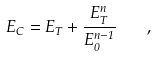<formula> <loc_0><loc_0><loc_500><loc_500>E _ { C } = E _ { T } + \frac { E _ { T } ^ { n } } { E _ { 0 } ^ { n - 1 } } \quad ,</formula> 